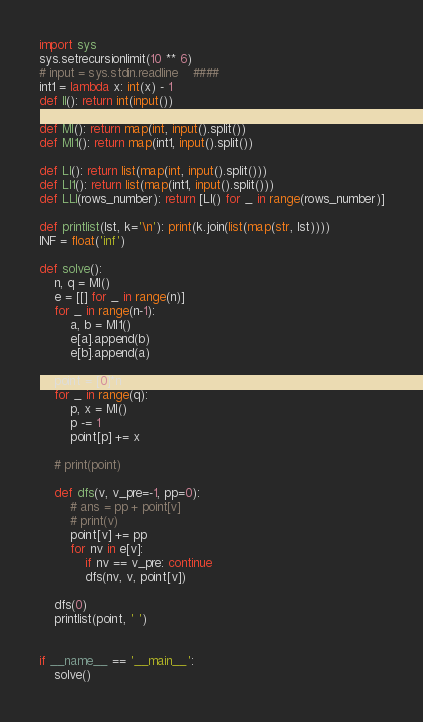Convert code to text. <code><loc_0><loc_0><loc_500><loc_500><_Python_>import sys
sys.setrecursionlimit(10 ** 6)
# input = sys.stdin.readline    ####
int1 = lambda x: int(x) - 1
def II(): return int(input())

def MI(): return map(int, input().split())
def MI1(): return map(int1, input().split())

def LI(): return list(map(int, input().split()))
def LI1(): return list(map(int1, input().split()))
def LLI(rows_number): return [LI() for _ in range(rows_number)]

def printlist(lst, k='\n'): print(k.join(list(map(str, lst))))
INF = float('inf')

def solve():
    n, q = MI()
    e = [[] for _ in range(n)]
    for _ in range(n-1):
        a, b = MI1()
        e[a].append(b)
        e[b].append(a)

    point = [0]*n
    for _ in range(q):
        p, x = MI()
        p -= 1
        point[p] += x

    # print(point)

    def dfs(v, v_pre=-1, pp=0):
        # ans = pp + point[v]
        # print(v)
        point[v] += pp
        for nv in e[v]:
            if nv == v_pre: continue
            dfs(nv, v, point[v])

    dfs(0)
    printlist(point, ' ')


if __name__ == '__main__':
    solve()
</code> 